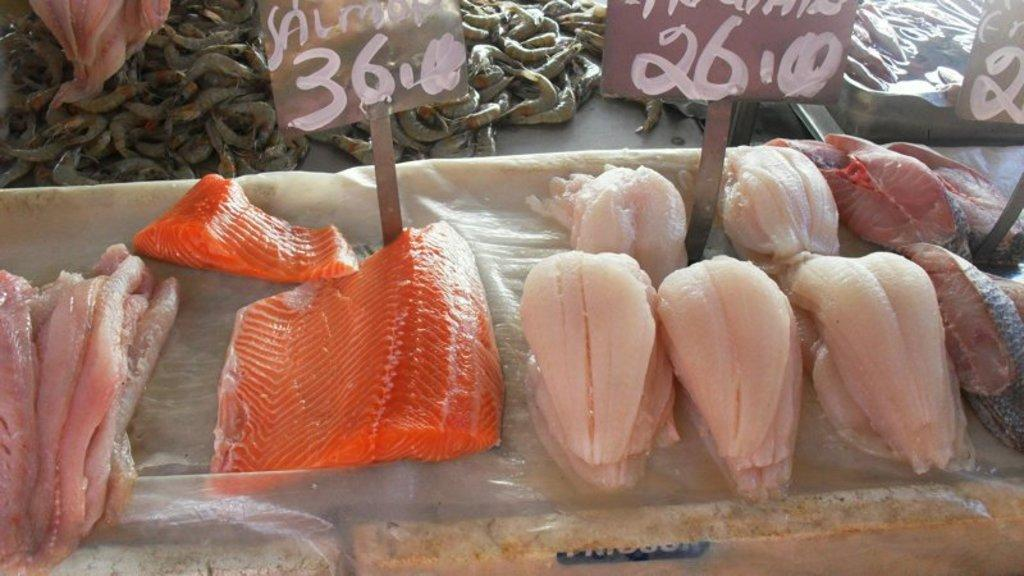What type of food is in the foreground of the picture? There is fish meat in the foreground of the picture. What else can be seen in the foreground of the picture? There are name plates in the foreground of the picture. What is located at the top of the picture? There are prawns at the top of the picture. How many brothers are shown in the picture? There are no people or brothers depicted in the image; it features fish meat, name plates, and prawns. Is there a goat present in the picture? There is no goat present in the picture. 